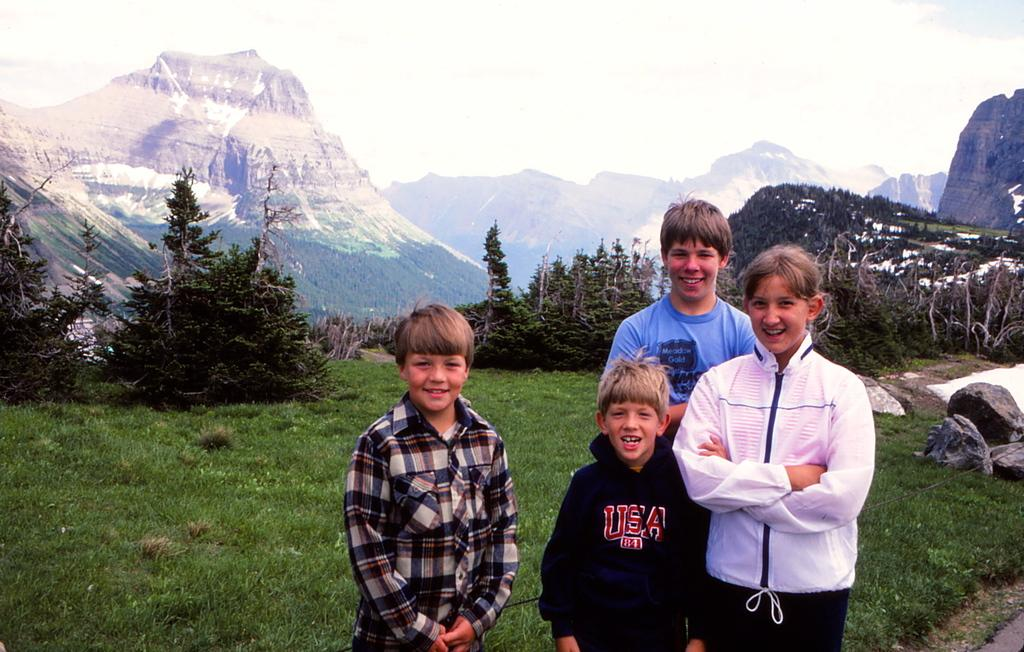How many children are in the image? There are four children on the right side of the image. What are the children doing in the image? The children are smiling and standing. What can be seen in the background of the image? There are trees, grass, rocks, mountains, and clouds in the sky. What type of wool is being used to create the office in the image? There is no wool or office present in the image; it features four children and a natural background. 